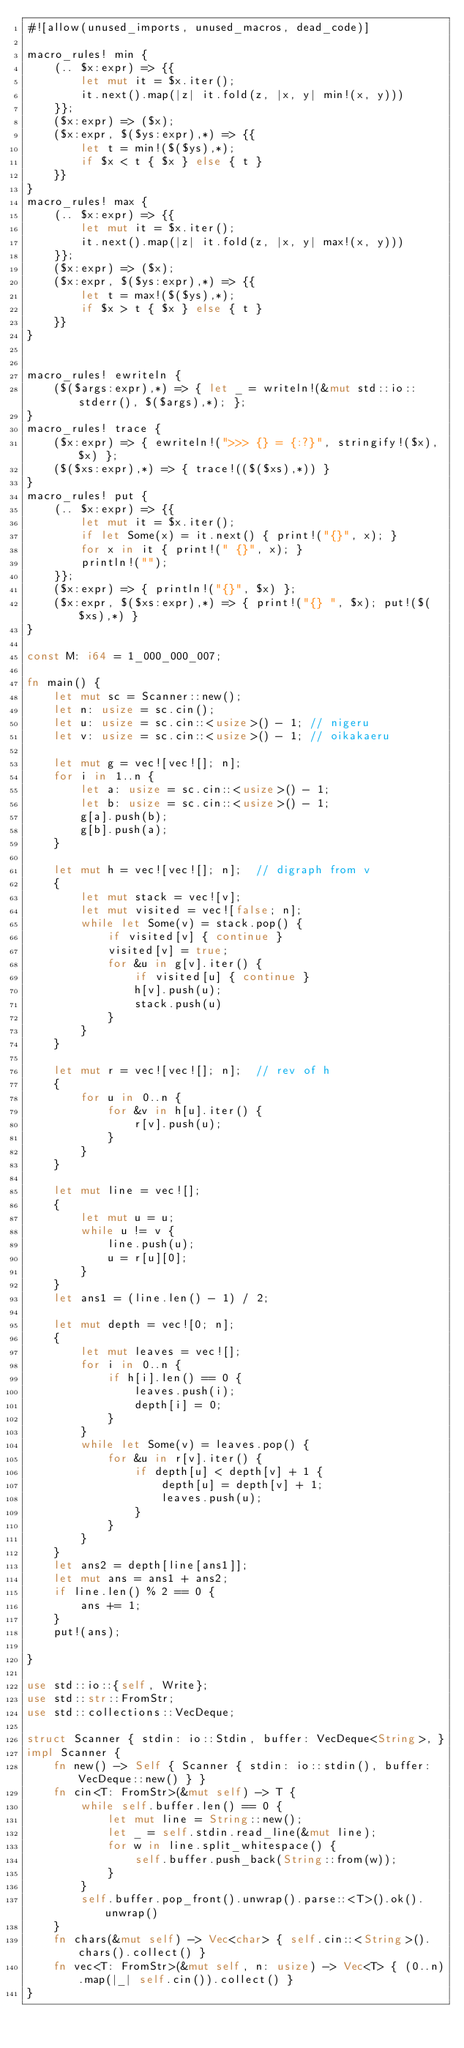<code> <loc_0><loc_0><loc_500><loc_500><_Rust_>#![allow(unused_imports, unused_macros, dead_code)]

macro_rules! min {
    (.. $x:expr) => {{
        let mut it = $x.iter();
        it.next().map(|z| it.fold(z, |x, y| min!(x, y)))
    }};
    ($x:expr) => ($x);
    ($x:expr, $($ys:expr),*) => {{
        let t = min!($($ys),*);
        if $x < t { $x } else { t }
    }}
}
macro_rules! max {
    (.. $x:expr) => {{
        let mut it = $x.iter();
        it.next().map(|z| it.fold(z, |x, y| max!(x, y)))
    }};
    ($x:expr) => ($x);
    ($x:expr, $($ys:expr),*) => {{
        let t = max!($($ys),*);
        if $x > t { $x } else { t }
    }}
}


macro_rules! ewriteln {
    ($($args:expr),*) => { let _ = writeln!(&mut std::io::stderr(), $($args),*); };
}
macro_rules! trace {
    ($x:expr) => { ewriteln!(">>> {} = {:?}", stringify!($x), $x) };
    ($($xs:expr),*) => { trace!(($($xs),*)) }
}
macro_rules! put {
    (.. $x:expr) => {{
        let mut it = $x.iter();
        if let Some(x) = it.next() { print!("{}", x); }
        for x in it { print!(" {}", x); }
        println!("");
    }};
    ($x:expr) => { println!("{}", $x) };
    ($x:expr, $($xs:expr),*) => { print!("{} ", $x); put!($($xs),*) }
}

const M: i64 = 1_000_000_007;

fn main() {
    let mut sc = Scanner::new();
    let n: usize = sc.cin();
    let u: usize = sc.cin::<usize>() - 1; // nigeru
    let v: usize = sc.cin::<usize>() - 1; // oikakaeru

    let mut g = vec![vec![]; n];
    for i in 1..n {
        let a: usize = sc.cin::<usize>() - 1;
        let b: usize = sc.cin::<usize>() - 1;
        g[a].push(b);
        g[b].push(a);
    }

    let mut h = vec![vec![]; n];  // digraph from v
    {
        let mut stack = vec![v];
        let mut visited = vec![false; n];
        while let Some(v) = stack.pop() {
            if visited[v] { continue }
            visited[v] = true;
            for &u in g[v].iter() {
                if visited[u] { continue }
                h[v].push(u);
                stack.push(u)
            }
        }
    }

    let mut r = vec![vec![]; n];  // rev of h
    {
        for u in 0..n {
            for &v in h[u].iter() {
                r[v].push(u);
            }
        }
    }

    let mut line = vec![];
    {
        let mut u = u;
        while u != v {
            line.push(u);
            u = r[u][0];
        }
    }
    let ans1 = (line.len() - 1) / 2;

    let mut depth = vec![0; n];
    {
        let mut leaves = vec![];
        for i in 0..n {
            if h[i].len() == 0 {
                leaves.push(i);
                depth[i] = 0;
            }
        }
        while let Some(v) = leaves.pop() {
            for &u in r[v].iter() {
                if depth[u] < depth[v] + 1 {
                    depth[u] = depth[v] + 1;
                    leaves.push(u);
                }
            }
        }
    }
    let ans2 = depth[line[ans1]];
    let mut ans = ans1 + ans2;
    if line.len() % 2 == 0 {
        ans += 1;
    }
    put!(ans);

}

use std::io::{self, Write};
use std::str::FromStr;
use std::collections::VecDeque;

struct Scanner { stdin: io::Stdin, buffer: VecDeque<String>, }
impl Scanner {
    fn new() -> Self { Scanner { stdin: io::stdin(), buffer: VecDeque::new() } }
    fn cin<T: FromStr>(&mut self) -> T {
        while self.buffer.len() == 0 {
            let mut line = String::new();
            let _ = self.stdin.read_line(&mut line);
            for w in line.split_whitespace() {
                self.buffer.push_back(String::from(w));
            }
        }
        self.buffer.pop_front().unwrap().parse::<T>().ok().unwrap()
    }
    fn chars(&mut self) -> Vec<char> { self.cin::<String>().chars().collect() }
    fn vec<T: FromStr>(&mut self, n: usize) -> Vec<T> { (0..n).map(|_| self.cin()).collect() }
}
</code> 